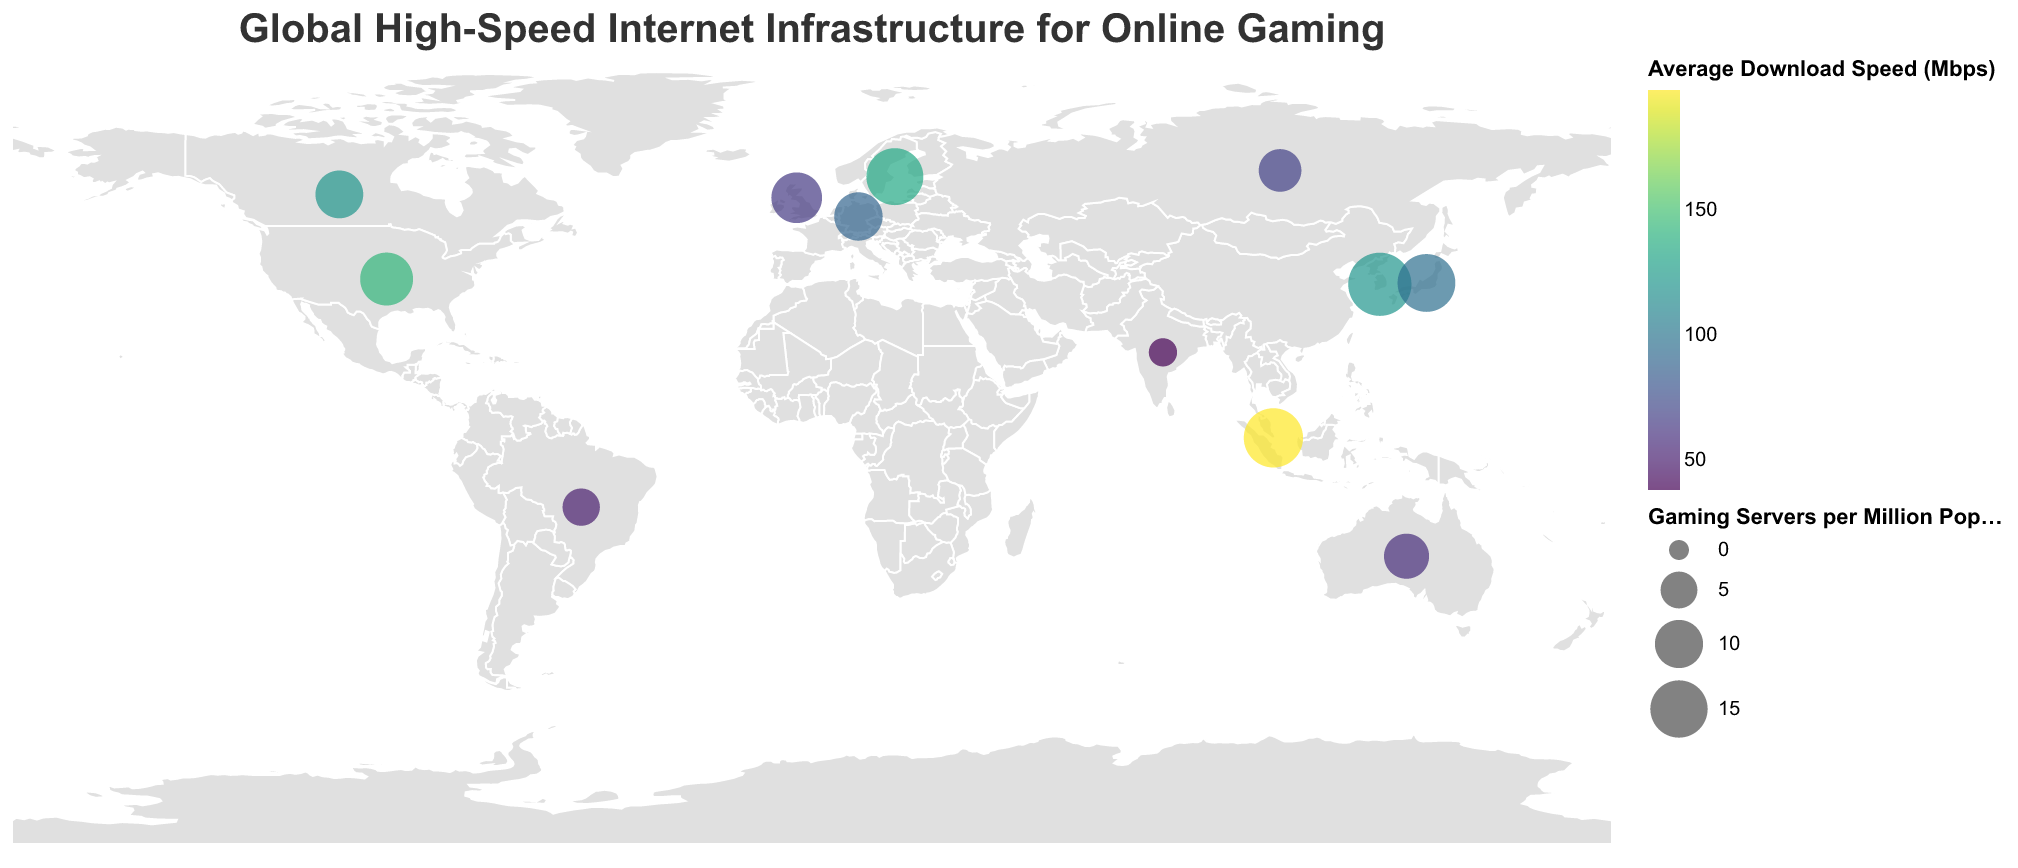**Basic Question**: What is the title of the figure? The title is typically displayed at the top center of a figure. It is written in a larger or distinct font for emphasis.
Answer: "Global High-Speed Internet Infrastructure for Online Gaming" **Basic Question**: How many countries are represented in the figure? Count the number of unique data points corresponding to different countries in the figure. There are 12 countries.
Answer: 12 **Comparison Question**: Which country has the highest average download speed? Observe the color scale indicating download speeds and find the data point corresponding to the highest value. Singapore has the highest speed at 198 Mbps.
Answer: Singapore **Comparison Question**: Which country has the lowest high-speed internet coverage percentage? Look for the data point with the smallest high-speed internet coverage value. India has the lowest coverage at 50%.
Answer: India **Compositional Question**: What is the average high-speed internet coverage percentage across all countries? Sum up the high-speed internet coverage percentages for all countries and divide by the number of countries, which is 12. (93 + 99 + 98 + 92 + 96 + 98 + 91 + 95 + 87 + 75 + 80 + 50) / 12 = 86.25.
Answer: 86.25% **Chart-Type Specific Question**: Which country has the largest circle representing gaming servers per million population? Identify the country with the largest circle size, as this denotes the highest number of gaming servers per million population. South Korea has the largest circle, representing 18.7 gaming servers per million population.
Answer: South Korea **Comparison Question**: How does the average download speed in the United Kingdom compare to that in Australia? Compare the average download speeds from the data: United Kingdom (64 Mbps) and Australia (58 Mbps). The UK has a higher average download speed.
Answer: United Kingdom has a higher download speed **Compositional Question**: What is the combined number of gaming servers per million population in Japan and Germany? Add the gaming servers per million population for both countries. Japan (15.3) + Germany (10.1) = 25.4.
Answer: 25.4 **Chart-Type Specific Question**: What is the major gaming hub for Sweden? Look at the detailed data point for Sweden in the figure to identify the major gaming hub.
Answer: Stockholm **Comparison Question**: Which country has a higher high-speed internet coverage, Canada or the United States? Compare the high-speed internet coverage percentages for Canada (91%) and the United States (93%). The United States has higher coverage.
Answer: United States 